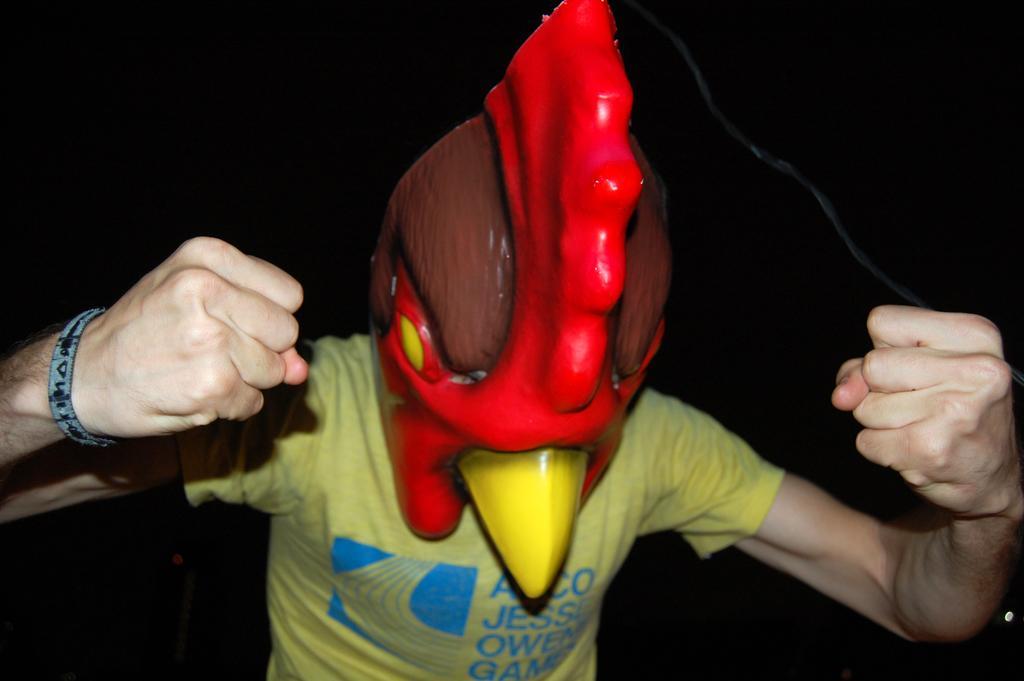Can you describe this image briefly? In this picture there is a person wearing an object on his head which is in red and brown color. 